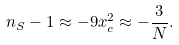<formula> <loc_0><loc_0><loc_500><loc_500>n _ { S } - 1 \approx - 9 x _ { c } ^ { 2 } \approx - \frac { 3 } { N } .</formula> 